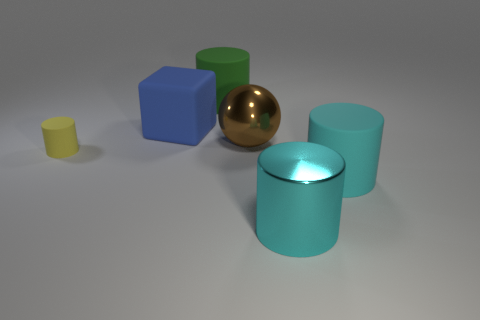What shape is the yellow thing?
Provide a short and direct response. Cylinder. What number of large things are left of the cyan matte cylinder and in front of the yellow rubber object?
Give a very brief answer. 1. Is the color of the big block the same as the metallic ball?
Provide a succinct answer. No. There is a large green thing that is the same shape as the small rubber thing; what is it made of?
Provide a succinct answer. Rubber. Are there any other things that have the same material as the big brown ball?
Your response must be concise. Yes. Are there an equal number of large brown objects behind the cube and cylinders behind the big brown metal thing?
Make the answer very short. No. Is the big brown object made of the same material as the cube?
Give a very brief answer. No. How many blue things are cylinders or large shiny things?
Your answer should be very brief. 0. How many brown metallic objects have the same shape as the yellow object?
Provide a succinct answer. 0. What is the yellow cylinder made of?
Your answer should be compact. Rubber. 